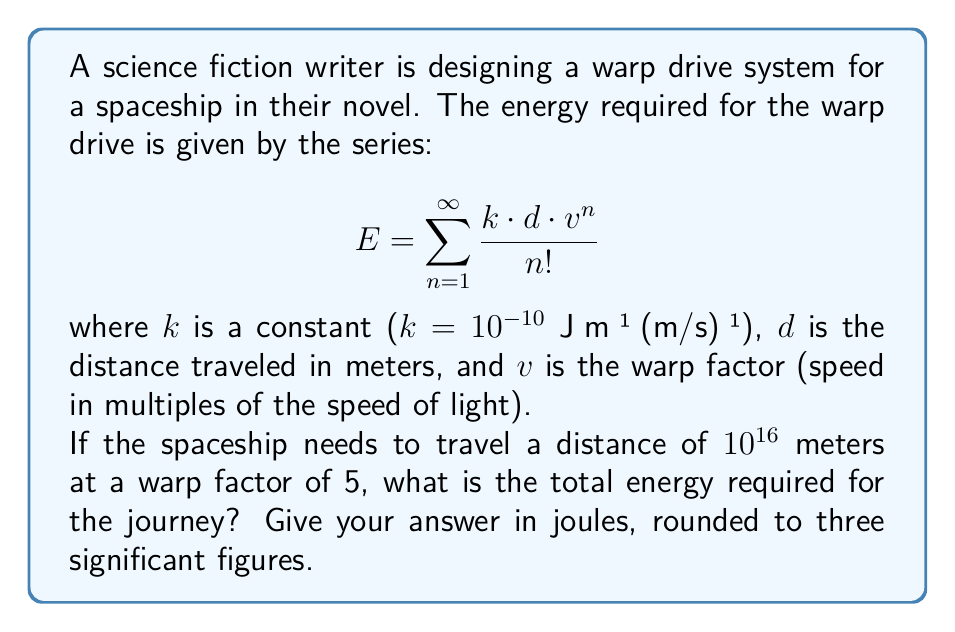Could you help me with this problem? To solve this problem, we need to evaluate the infinite series given in the question. Let's break it down step by step:

1) First, let's substitute the known values:
   $k = 10^{-10}$ J⋅m⁻¹⋅(m/s)⁻¹
   $d = 10^{16}$ m
   $v = 5$

2) Now our series looks like this:
   $$E = \sum_{n=1}^{\infty} \frac{10^{-10} \cdot 10^{16} \cdot 5^n}{n!}$$

3) Simplify:
   $$E = 10^6 \sum_{n=1}^{\infty} \frac{5^n}{n!}$$

4) Recognize that this series is related to the exponential function. Recall that:
   $$e^x = \sum_{n=0}^{\infty} \frac{x^n}{n!}$$

5) Our series is almost the same, but it starts from n=1 instead of n=0. We can adjust for this:
   $$\sum_{n=1}^{\infty} \frac{5^n}{n!} = e^5 - 1$$

6) Therefore, our energy equation becomes:
   $$E = 10^6 (e^5 - 1)$$

7) Calculate:
   $e^5 \approx 148.4131591$
   $e^5 - 1 \approx 147.4131591$
   $E = 10^6 \cdot 147.4131591 = 147,413,159.1$ J

8) Rounding to three significant figures:
   $E \approx 1.47 \times 10^8$ J
Answer: $1.47 \times 10^8$ J 